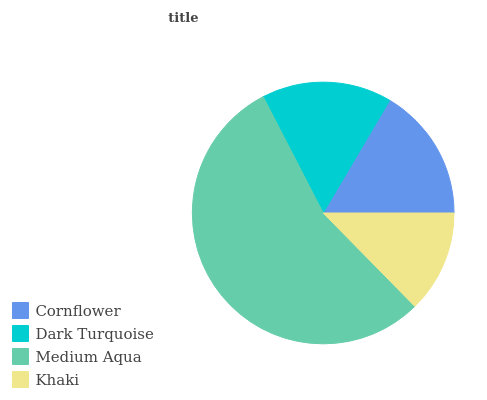Is Khaki the minimum?
Answer yes or no. Yes. Is Medium Aqua the maximum?
Answer yes or no. Yes. Is Dark Turquoise the minimum?
Answer yes or no. No. Is Dark Turquoise the maximum?
Answer yes or no. No. Is Cornflower greater than Dark Turquoise?
Answer yes or no. Yes. Is Dark Turquoise less than Cornflower?
Answer yes or no. Yes. Is Dark Turquoise greater than Cornflower?
Answer yes or no. No. Is Cornflower less than Dark Turquoise?
Answer yes or no. No. Is Cornflower the high median?
Answer yes or no. Yes. Is Dark Turquoise the low median?
Answer yes or no. Yes. Is Medium Aqua the high median?
Answer yes or no. No. Is Khaki the low median?
Answer yes or no. No. 